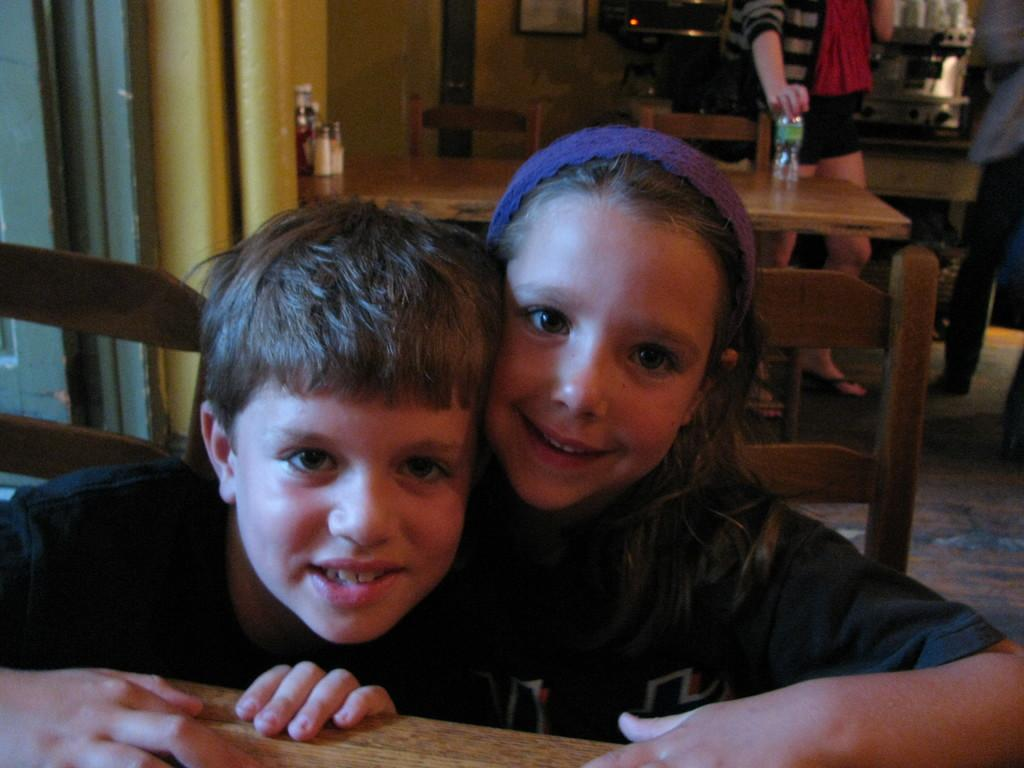How many children are in the image? There are two children in the image. What are the children doing in the image? The children are sitting on chairs. Where are the chairs located in relation to the table? The chairs are near a table. What is happening in the background of the image? There is a person standing in the background of the image. What is the person holding in the image? The person is holding a bottle. What type of government is being discussed by the children in the image? There is no indication in the image that the children are discussing any type of government. 